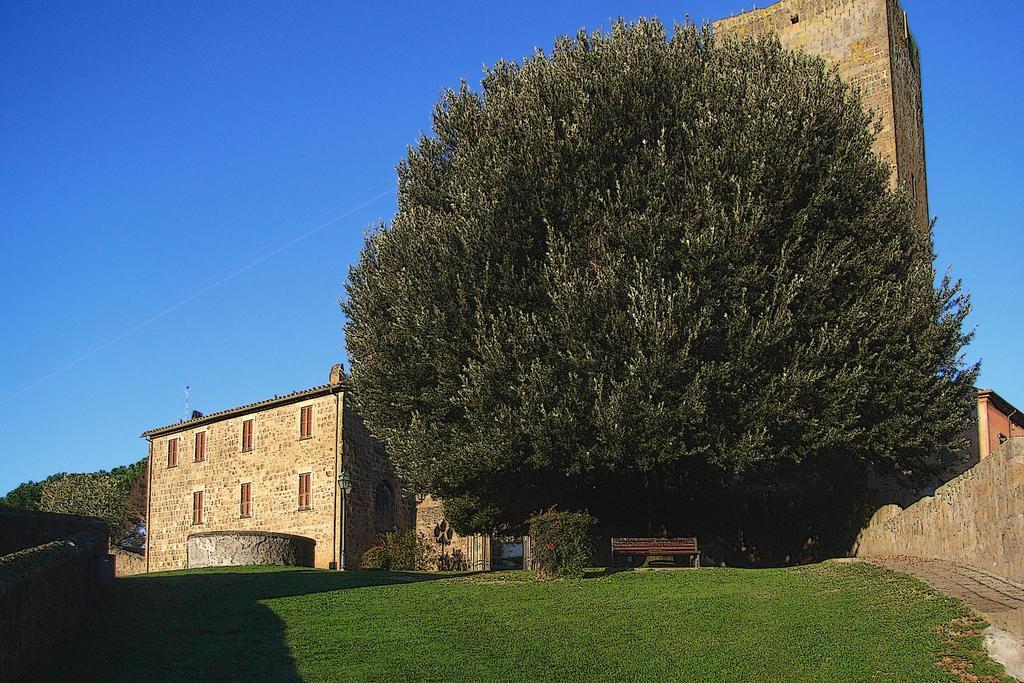In one or two sentences, can you explain what this image depicts? In the image there is a building and in front of the building there is a huge tree, below the tree there is a bench and there is a lot of grass in front of the building. 